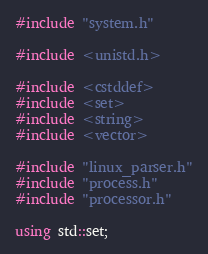<code> <loc_0><loc_0><loc_500><loc_500><_C++_>#include "system.h"

#include <unistd.h>

#include <cstddef>
#include <set>
#include <string>
#include <vector>

#include "linux_parser.h"
#include "process.h"
#include "processor.h"

using std::set;</code> 